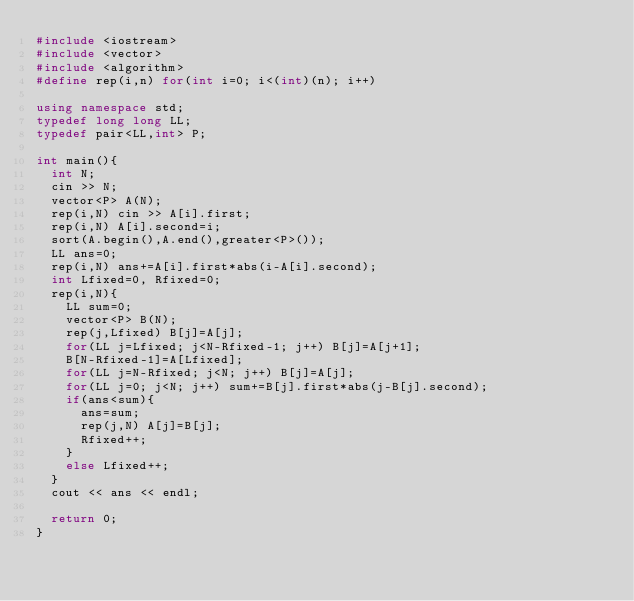Convert code to text. <code><loc_0><loc_0><loc_500><loc_500><_C++_>#include <iostream>
#include <vector>
#include <algorithm>
#define rep(i,n) for(int i=0; i<(int)(n); i++)

using namespace std;
typedef long long LL;
typedef pair<LL,int> P;

int main(){
  int N;
  cin >> N;
  vector<P> A(N);
  rep(i,N) cin >> A[i].first;
  rep(i,N) A[i].second=i;
  sort(A.begin(),A.end(),greater<P>());
  LL ans=0;
  rep(i,N) ans+=A[i].first*abs(i-A[i].second);
  int Lfixed=0, Rfixed=0;
  rep(i,N){
    LL sum=0;
    vector<P> B(N);
    rep(j,Lfixed) B[j]=A[j];
    for(LL j=Lfixed; j<N-Rfixed-1; j++) B[j]=A[j+1];
    B[N-Rfixed-1]=A[Lfixed];
    for(LL j=N-Rfixed; j<N; j++) B[j]=A[j];
    for(LL j=0; j<N; j++) sum+=B[j].first*abs(j-B[j].second);
    if(ans<sum){
      ans=sum;
      rep(j,N) A[j]=B[j];
      Rfixed++;
    }
    else Lfixed++;
  }
  cout << ans << endl;

  return 0;
}
</code> 